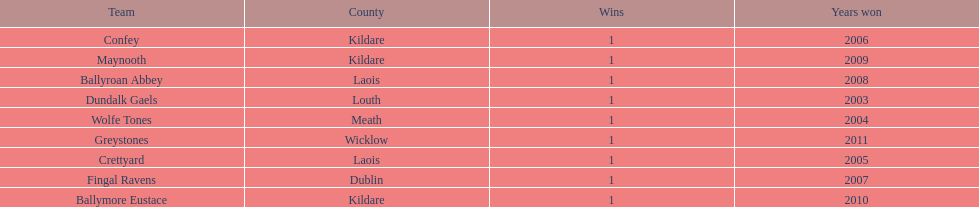What is the years won for each team 2011, 2010, 2009, 2008, 2007, 2006, 2005, 2004, 2003. 